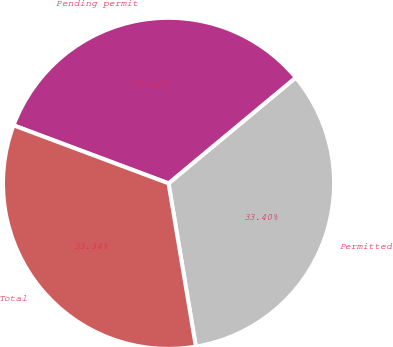<chart> <loc_0><loc_0><loc_500><loc_500><pie_chart><fcel>Permitted<fcel>Pending permit<fcel>Total<nl><fcel>33.4%<fcel>33.26%<fcel>33.34%<nl></chart> 